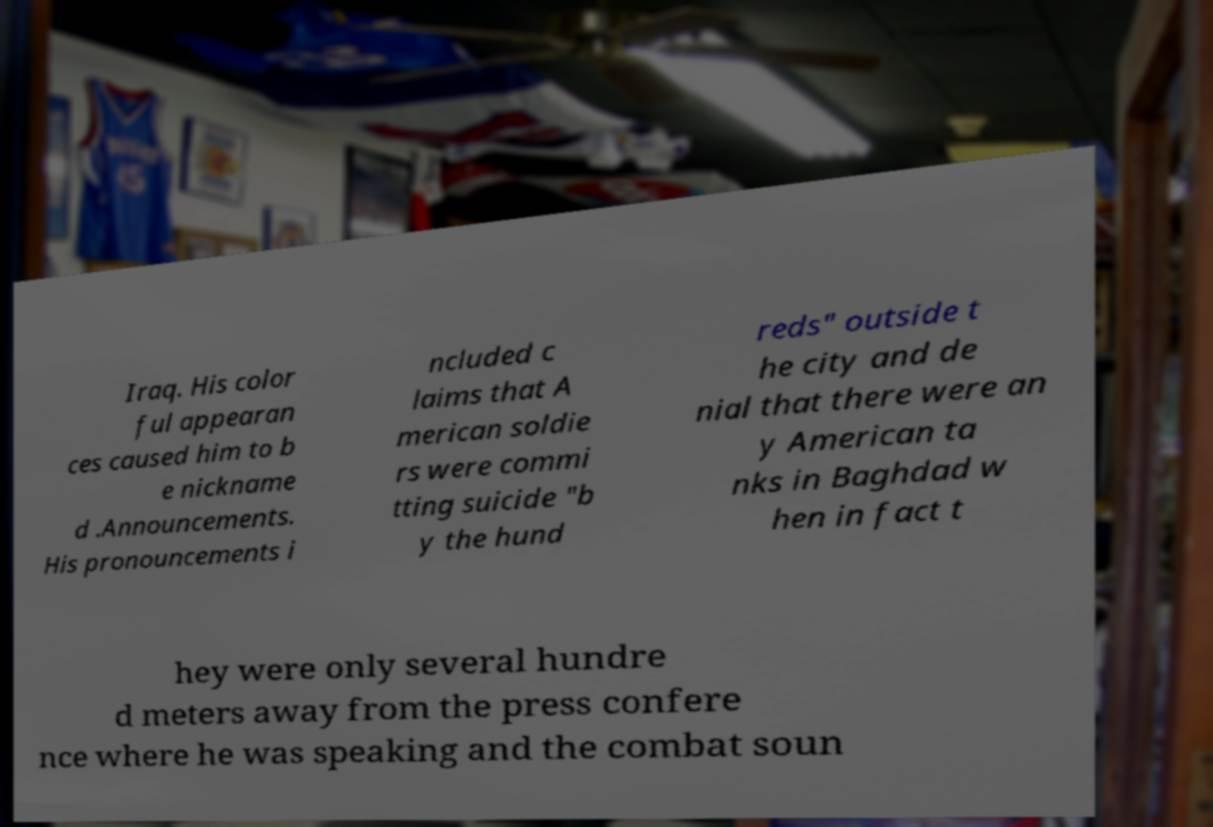Could you assist in decoding the text presented in this image and type it out clearly? Iraq. His color ful appearan ces caused him to b e nickname d .Announcements. His pronouncements i ncluded c laims that A merican soldie rs were commi tting suicide "b y the hund reds" outside t he city and de nial that there were an y American ta nks in Baghdad w hen in fact t hey were only several hundre d meters away from the press confere nce where he was speaking and the combat soun 